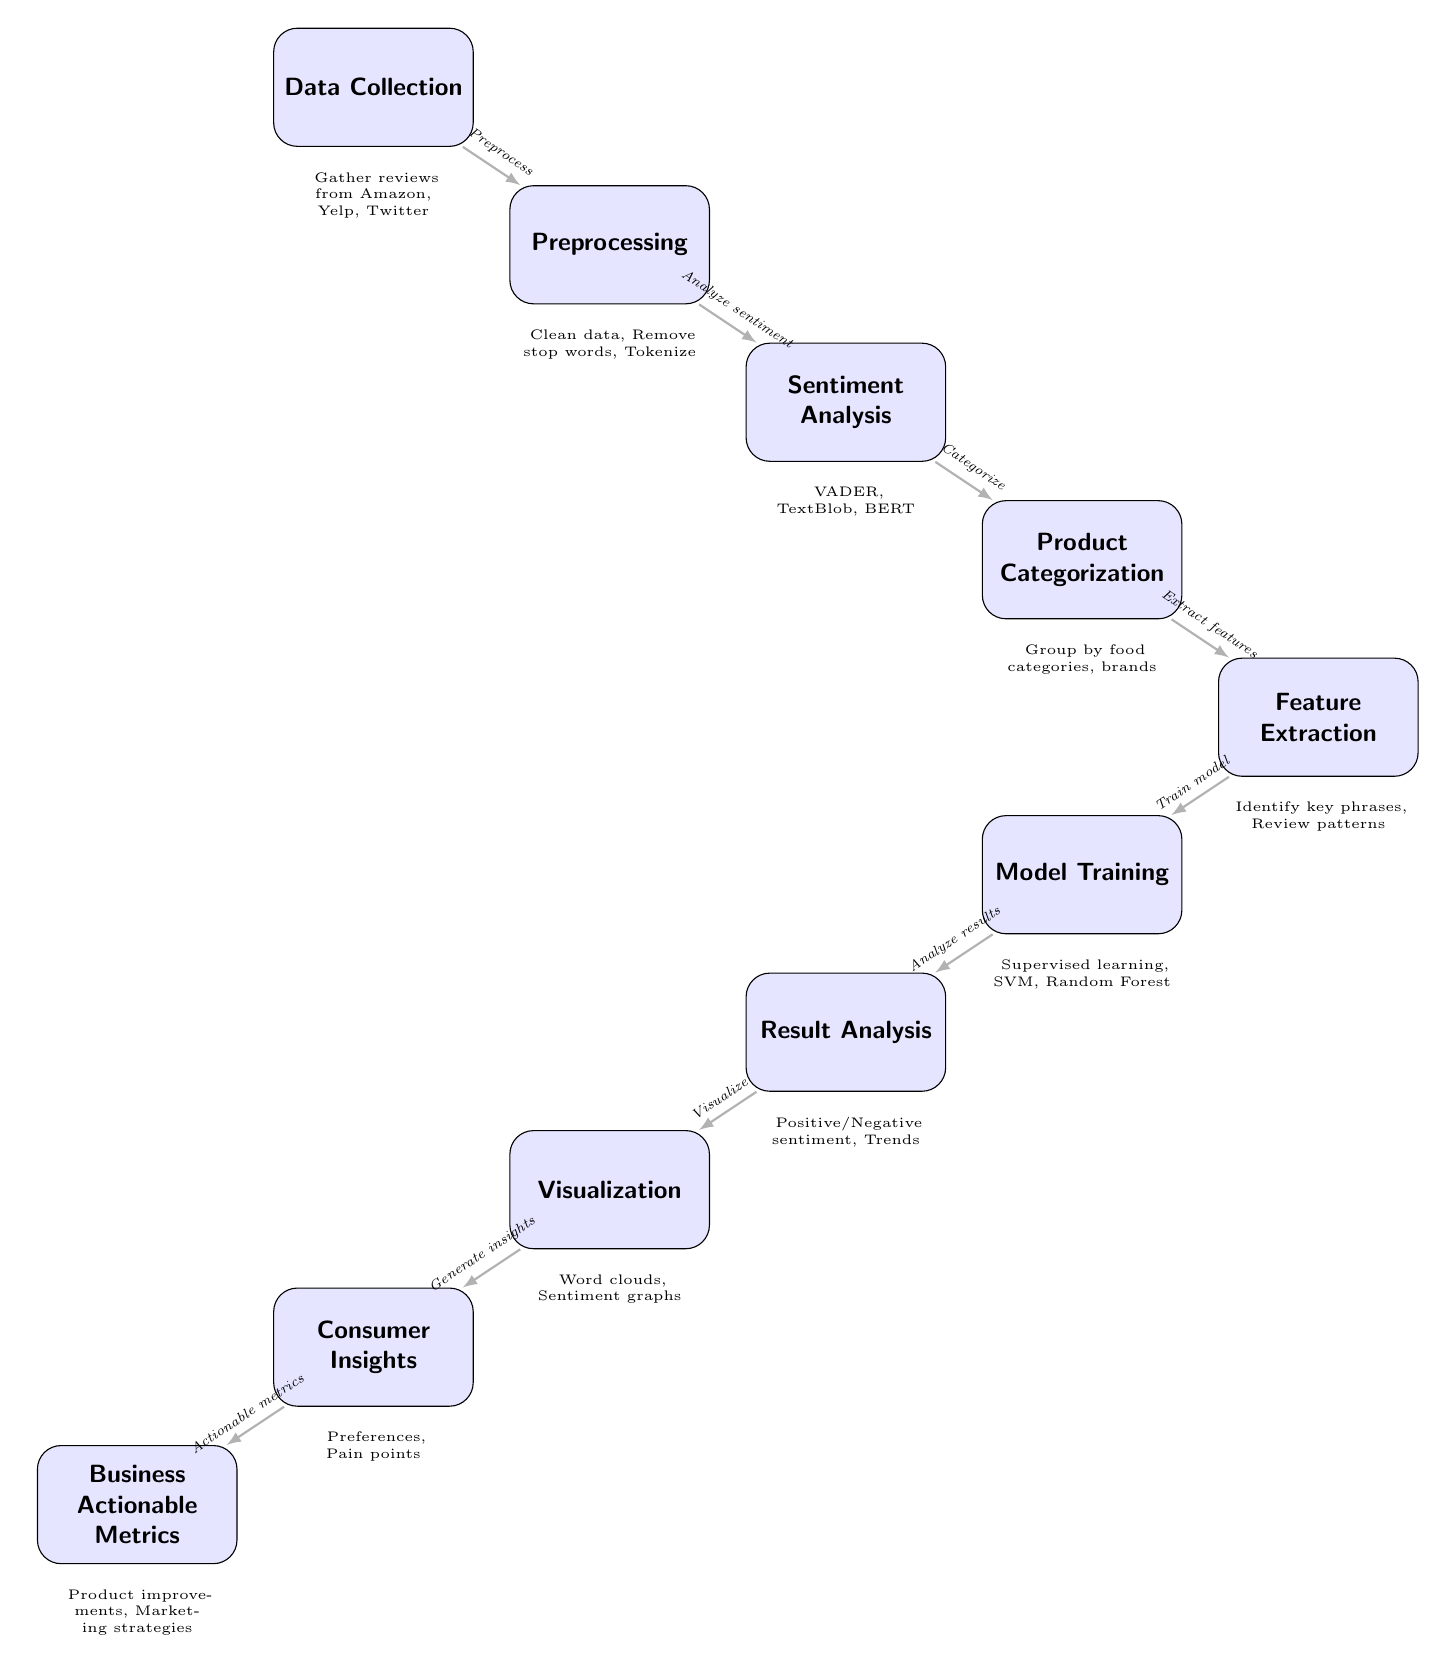What is the first step in the food chain? The diagram shows "Data Collection" as the first node, indicating that this is the initial step in the food chain of analyzing consumer sentiment.
Answer: Data Collection How many nodes are present in the diagram? By counting the nodes from the diagram, there are a total of ten distinct nodes that represent different steps in the process.
Answer: 10 What node comes after "Preprocessing"? The diagram indicates that the node following "Preprocessing" is "Sentiment Analysis," directly illustrating the flow of the process between these two steps.
Answer: Sentiment Analysis Which technique is used in the "Sentiment Analysis" node? The diagram lists the techniques associated with "Sentiment Analysis," specifically naming "VADER, TextBlob, BERT" as examples used in this step.
Answer: VADER, TextBlob, BERT What is the output of the "Visualization" node? The "Visualization" node produces "Word clouds, Sentiment graphs," as indicated in the diagram, which are visual representations made after analyzing results.
Answer: Word clouds, Sentiment graphs What relationship exists between "Product Categorization" and "Feature Extraction"? The diagram shows a direct flow from "Product Categorization" to "Feature Extraction," indicating that features are extracted based on the categorized products, highlighting a dependent process.
Answer: Extract features How many edges connect "Result Analysis" to subsequent nodes? In the diagram, there is one outgoing edge from "Result Analysis" leading to "Visualization," showing that it only connects to one subsequent node.
Answer: 1 What insights are generated before "Business Actionable Metrics"? The flow in the diagram indicates that the "Consumer Insights" node precedes "Business Actionable Metrics," determining what insights are determined before creating metrics for business use.
Answer: Consumer Insights Which node signifies the final output of the food chain? The last node in the diagram, which signifies the culmination of the process, is "Business Actionable Metrics," highlighting the final output of the food chain.
Answer: Business Actionable Metrics What is the purpose of the "Model Training" step? The diagram indicates that "Model Training" is concerned with "Supervised learning, SVM, Random Forest," which explains the purpose of this step: to develop and refine predictive models using labeled data.
Answer: Supervised learning, SVM, Random Forest 